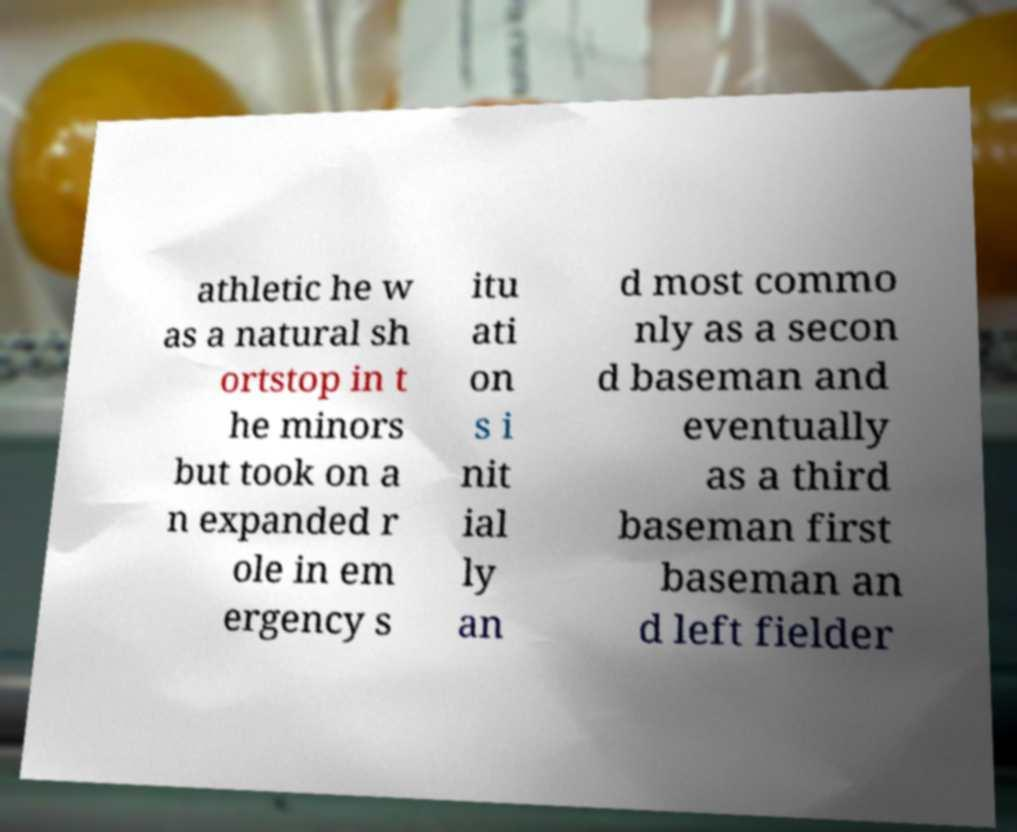I need the written content from this picture converted into text. Can you do that? athletic he w as a natural sh ortstop in t he minors but took on a n expanded r ole in em ergency s itu ati on s i nit ial ly an d most commo nly as a secon d baseman and eventually as a third baseman first baseman an d left fielder 